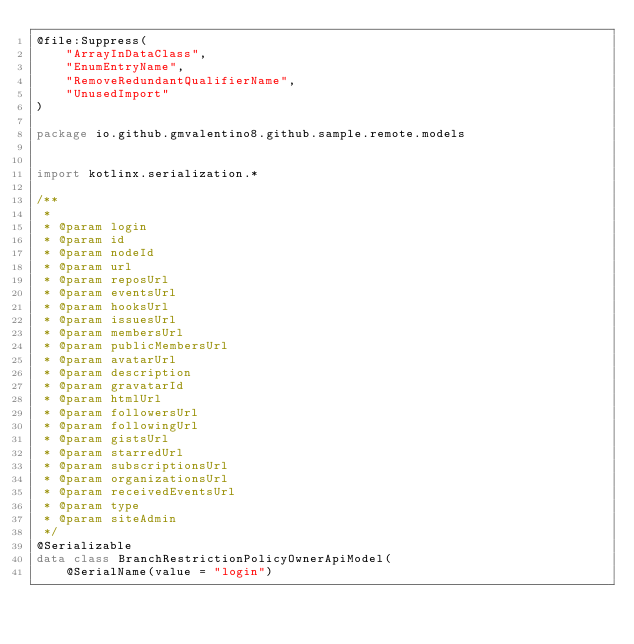Convert code to text. <code><loc_0><loc_0><loc_500><loc_500><_Kotlin_>@file:Suppress(
    "ArrayInDataClass",
    "EnumEntryName",
    "RemoveRedundantQualifierName",
    "UnusedImport"
)

package io.github.gmvalentino8.github.sample.remote.models


import kotlinx.serialization.*

/**
 * 
 * @param login 
 * @param id 
 * @param nodeId 
 * @param url 
 * @param reposUrl 
 * @param eventsUrl 
 * @param hooksUrl 
 * @param issuesUrl 
 * @param membersUrl 
 * @param publicMembersUrl 
 * @param avatarUrl 
 * @param description 
 * @param gravatarId 
 * @param htmlUrl 
 * @param followersUrl 
 * @param followingUrl 
 * @param gistsUrl 
 * @param starredUrl 
 * @param subscriptionsUrl 
 * @param organizationsUrl 
 * @param receivedEventsUrl 
 * @param type 
 * @param siteAdmin 
 */
@Serializable
data class BranchRestrictionPolicyOwnerApiModel(
    @SerialName(value = "login")</code> 